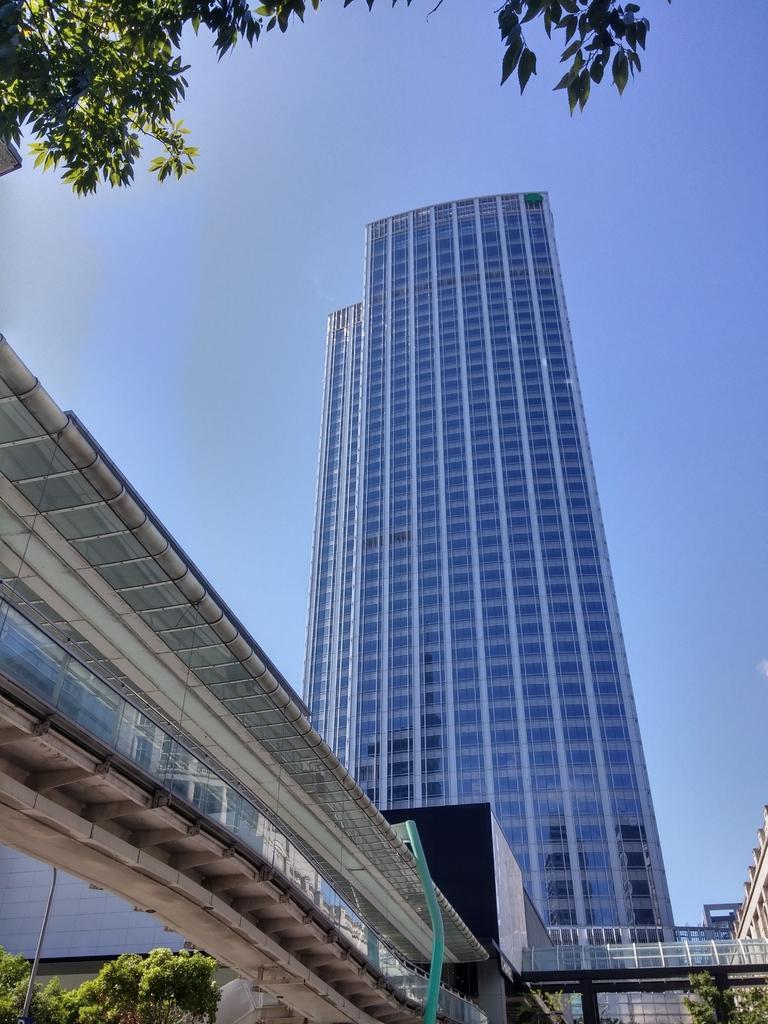Describe this image in one or two sentences. In the center of the image we can see buildings, bridge, wall, windows. At the bottom of the image we can see trees. In the background of the image we can see the sky. 